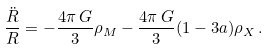<formula> <loc_0><loc_0><loc_500><loc_500>\frac { \ddot { R } } { R } = - \frac { 4 \pi \, G } { 3 } \rho _ { M } - \frac { 4 \pi \, G } { 3 } ( 1 - 3 a ) \rho _ { X } \, .</formula> 